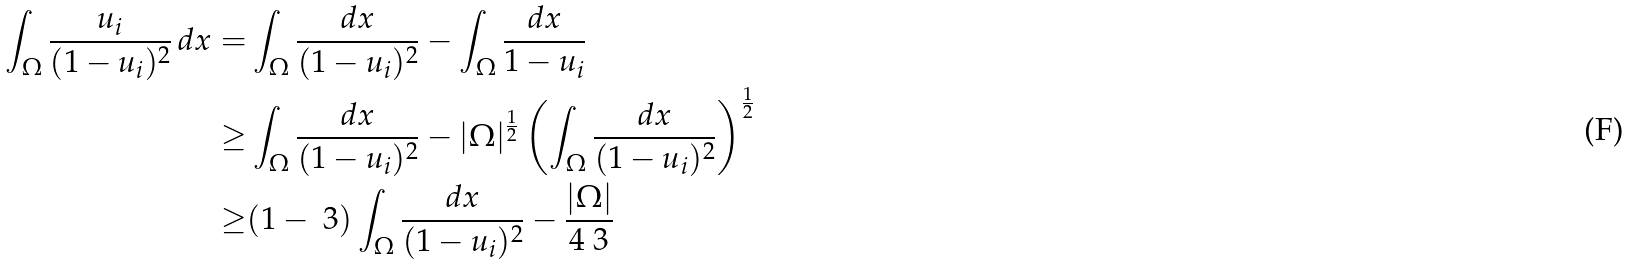<formula> <loc_0><loc_0><loc_500><loc_500>\int _ { \Omega } \frac { u _ { i } } { ( 1 - u _ { i } ) ^ { 2 } } \, d x = & \int _ { \Omega } \frac { d x } { ( 1 - u _ { i } ) ^ { 2 } } - \int _ { \Omega } \frac { d x } { 1 - u _ { i } } \\ \geq & \int _ { \Omega } \frac { d x } { ( 1 - u _ { i } ) ^ { 2 } } - | \Omega | ^ { \frac { 1 } { 2 } } \left ( \int _ { \Omega } \frac { d x } { ( 1 - u _ { i } ) ^ { 2 } } \right ) ^ { \frac { 1 } { 2 } } \\ \geq & ( 1 - \ 3 ) \int _ { \Omega } \frac { d x } { ( 1 - u _ { i } ) ^ { 2 } } - \frac { | \Omega | } { 4 \ 3 }</formula> 